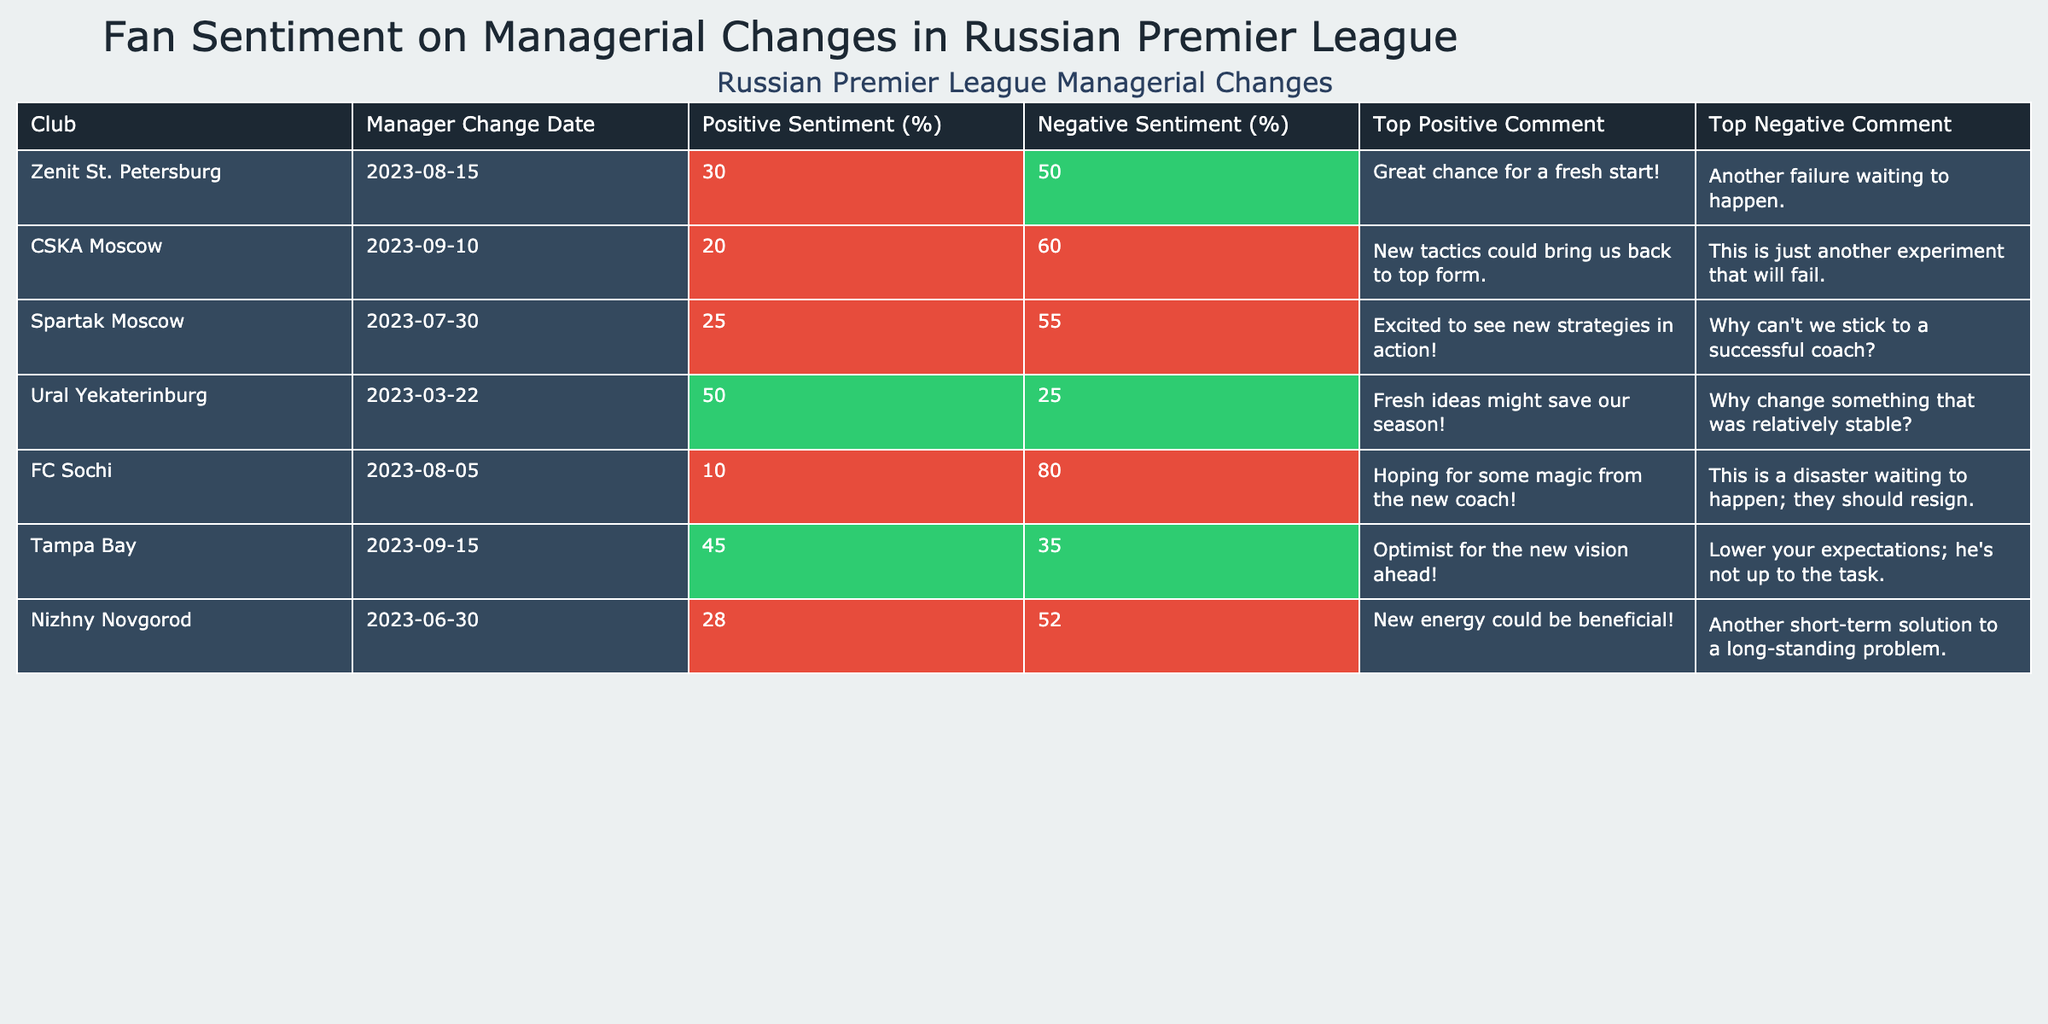What is the highest percentage of positive sentiment regarding a managerial change? The 'Positive Sentiment (%)' column shows the following values: 30, 20, 25, 50, 10, 45, and 28. The highest value among these is 50.
Answer: 50 Which club had the lowest percentage of positive sentiment? By checking the 'Positive Sentiment (%)' column, FC Sochi has the lowest value at 10.
Answer: FC Sochi What is the difference between the highest and lowest negative sentiment percentages? The 'Negative Sentiment (%)' values are 50, 60, 55, 25, 80, 35, and 52. The highest is 80 and the lowest is 25. The difference is 80 - 25 = 55.
Answer: 55 Which club has the highest negative sentiment, and what is the percentage? Looking at 'Negative Sentiment (%)', FC Sochi has the highest percentage at 80.
Answer: FC Sochi, 80 Is there any club that has more than 50% negative sentiment? Scanning the 'Negative Sentiment (%)' column, FC Sochi (80) and CSKA Moscow (60) both exceed 50%.
Answer: Yes What is the average positive sentiment of clubs that changed their managers? The positive sentiment values are 30, 20, 25, 50, 10, 45, and 28. Their sum is 30 + 20 + 25 + 50 + 10 + 45 + 28 = 208. There are 7 values, so the average is 208 / 7 ≈ 29.71.
Answer: Approximately 29.71 Which club has a positive sentiment close to the average? The average positive sentiment calculated is approximately 29.71. Clubs near this value are Zenit St. Petersburg (30) and Nizhny Novgorod (28).
Answer: Zenit St. Petersburg and Nizhny Novgorod What percentage of clubs have a positive sentiment greater than 25%? The clubs with positive sentiments above 25% are Zenit St. Petersburg (30), Ural Yekaterinburg (50), and Tampa Bay (45). That’s 3 out of 7 clubs, which is roughly 42.86%.
Answer: About 42.86% How many clubs had a managerial change in the date range specified? The table lists 7 clubs that experienced managerial changes within the past year.
Answer: 7 Which club has received the most optimistic top positive comment? The top positive comments noted include intentions for fresh starts or new strategies, but subjectively, Ural Yekaterinburg's comment about "fresh ideas" might seem the most optimistic.
Answer: Ural Yekaterinburg 